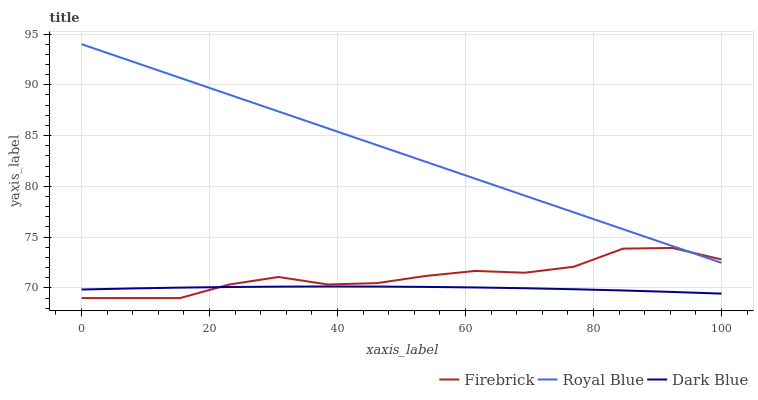Does Dark Blue have the minimum area under the curve?
Answer yes or no. Yes. Does Royal Blue have the maximum area under the curve?
Answer yes or no. Yes. Does Firebrick have the minimum area under the curve?
Answer yes or no. No. Does Firebrick have the maximum area under the curve?
Answer yes or no. No. Is Royal Blue the smoothest?
Answer yes or no. Yes. Is Firebrick the roughest?
Answer yes or no. Yes. Is Dark Blue the smoothest?
Answer yes or no. No. Is Dark Blue the roughest?
Answer yes or no. No. Does Firebrick have the lowest value?
Answer yes or no. Yes. Does Dark Blue have the lowest value?
Answer yes or no. No. Does Royal Blue have the highest value?
Answer yes or no. Yes. Does Firebrick have the highest value?
Answer yes or no. No. Is Dark Blue less than Royal Blue?
Answer yes or no. Yes. Is Royal Blue greater than Dark Blue?
Answer yes or no. Yes. Does Royal Blue intersect Firebrick?
Answer yes or no. Yes. Is Royal Blue less than Firebrick?
Answer yes or no. No. Is Royal Blue greater than Firebrick?
Answer yes or no. No. Does Dark Blue intersect Royal Blue?
Answer yes or no. No. 